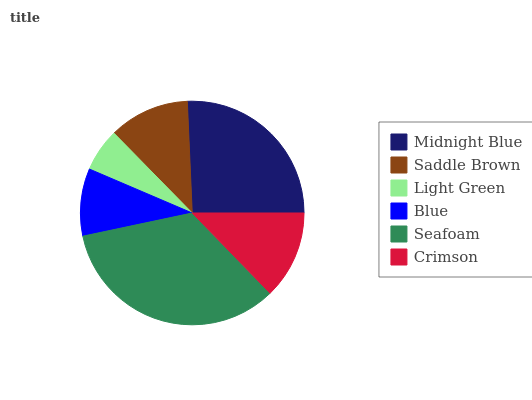Is Light Green the minimum?
Answer yes or no. Yes. Is Seafoam the maximum?
Answer yes or no. Yes. Is Saddle Brown the minimum?
Answer yes or no. No. Is Saddle Brown the maximum?
Answer yes or no. No. Is Midnight Blue greater than Saddle Brown?
Answer yes or no. Yes. Is Saddle Brown less than Midnight Blue?
Answer yes or no. Yes. Is Saddle Brown greater than Midnight Blue?
Answer yes or no. No. Is Midnight Blue less than Saddle Brown?
Answer yes or no. No. Is Crimson the high median?
Answer yes or no. Yes. Is Saddle Brown the low median?
Answer yes or no. Yes. Is Saddle Brown the high median?
Answer yes or no. No. Is Seafoam the low median?
Answer yes or no. No. 